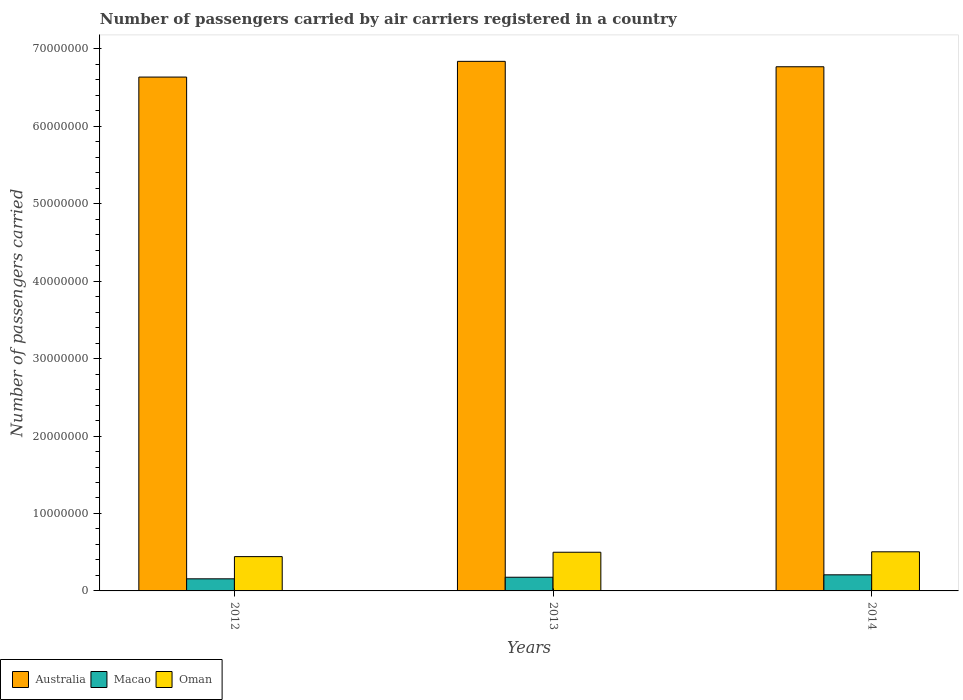How many different coloured bars are there?
Your response must be concise. 3. How many groups of bars are there?
Make the answer very short. 3. Are the number of bars on each tick of the X-axis equal?
Provide a succinct answer. Yes. How many bars are there on the 1st tick from the left?
Give a very brief answer. 3. How many bars are there on the 2nd tick from the right?
Provide a succinct answer. 3. What is the label of the 1st group of bars from the left?
Provide a succinct answer. 2012. In how many cases, is the number of bars for a given year not equal to the number of legend labels?
Provide a succinct answer. 0. What is the number of passengers carried by air carriers in Macao in 2012?
Offer a terse response. 1.56e+06. Across all years, what is the maximum number of passengers carried by air carriers in Oman?
Make the answer very short. 5.05e+06. Across all years, what is the minimum number of passengers carried by air carriers in Macao?
Keep it short and to the point. 1.56e+06. In which year was the number of passengers carried by air carriers in Macao maximum?
Your answer should be very brief. 2014. In which year was the number of passengers carried by air carriers in Oman minimum?
Make the answer very short. 2012. What is the total number of passengers carried by air carriers in Oman in the graph?
Offer a terse response. 1.45e+07. What is the difference between the number of passengers carried by air carriers in Oman in 2012 and that in 2014?
Keep it short and to the point. -6.21e+05. What is the difference between the number of passengers carried by air carriers in Macao in 2012 and the number of passengers carried by air carriers in Oman in 2013?
Provide a short and direct response. -3.43e+06. What is the average number of passengers carried by air carriers in Oman per year?
Offer a terse response. 4.83e+06. In the year 2012, what is the difference between the number of passengers carried by air carriers in Australia and number of passengers carried by air carriers in Oman?
Your answer should be very brief. 6.19e+07. What is the ratio of the number of passengers carried by air carriers in Oman in 2012 to that in 2014?
Your answer should be compact. 0.88. What is the difference between the highest and the second highest number of passengers carried by air carriers in Oman?
Your answer should be very brief. 5.69e+04. What is the difference between the highest and the lowest number of passengers carried by air carriers in Oman?
Give a very brief answer. 6.21e+05. In how many years, is the number of passengers carried by air carriers in Australia greater than the average number of passengers carried by air carriers in Australia taken over all years?
Your answer should be compact. 2. Is the sum of the number of passengers carried by air carriers in Australia in 2013 and 2014 greater than the maximum number of passengers carried by air carriers in Macao across all years?
Your answer should be compact. Yes. What does the 1st bar from the left in 2012 represents?
Offer a very short reply. Australia. What does the 2nd bar from the right in 2013 represents?
Make the answer very short. Macao. How many years are there in the graph?
Ensure brevity in your answer.  3. Are the values on the major ticks of Y-axis written in scientific E-notation?
Give a very brief answer. No. Does the graph contain any zero values?
Offer a terse response. No. Does the graph contain grids?
Your answer should be compact. No. Where does the legend appear in the graph?
Ensure brevity in your answer.  Bottom left. How many legend labels are there?
Provide a succinct answer. 3. How are the legend labels stacked?
Keep it short and to the point. Horizontal. What is the title of the graph?
Provide a succinct answer. Number of passengers carried by air carriers registered in a country. What is the label or title of the Y-axis?
Make the answer very short. Number of passengers carried. What is the Number of passengers carried in Australia in 2012?
Keep it short and to the point. 6.64e+07. What is the Number of passengers carried of Macao in 2012?
Provide a short and direct response. 1.56e+06. What is the Number of passengers carried in Oman in 2012?
Provide a succinct answer. 4.43e+06. What is the Number of passengers carried of Australia in 2013?
Your answer should be very brief. 6.84e+07. What is the Number of passengers carried of Macao in 2013?
Ensure brevity in your answer.  1.77e+06. What is the Number of passengers carried of Oman in 2013?
Offer a terse response. 4.99e+06. What is the Number of passengers carried in Australia in 2014?
Your answer should be very brief. 6.77e+07. What is the Number of passengers carried of Macao in 2014?
Provide a succinct answer. 2.08e+06. What is the Number of passengers carried in Oman in 2014?
Offer a terse response. 5.05e+06. Across all years, what is the maximum Number of passengers carried in Australia?
Your answer should be compact. 6.84e+07. Across all years, what is the maximum Number of passengers carried in Macao?
Your response must be concise. 2.08e+06. Across all years, what is the maximum Number of passengers carried in Oman?
Your response must be concise. 5.05e+06. Across all years, what is the minimum Number of passengers carried in Australia?
Your answer should be compact. 6.64e+07. Across all years, what is the minimum Number of passengers carried in Macao?
Keep it short and to the point. 1.56e+06. Across all years, what is the minimum Number of passengers carried of Oman?
Ensure brevity in your answer.  4.43e+06. What is the total Number of passengers carried in Australia in the graph?
Give a very brief answer. 2.02e+08. What is the total Number of passengers carried of Macao in the graph?
Your answer should be compact. 5.41e+06. What is the total Number of passengers carried of Oman in the graph?
Offer a very short reply. 1.45e+07. What is the difference between the Number of passengers carried of Australia in 2012 and that in 2013?
Provide a short and direct response. -2.03e+06. What is the difference between the Number of passengers carried in Macao in 2012 and that in 2013?
Your response must be concise. -2.05e+05. What is the difference between the Number of passengers carried in Oman in 2012 and that in 2013?
Give a very brief answer. -5.64e+05. What is the difference between the Number of passengers carried of Australia in 2012 and that in 2014?
Provide a short and direct response. -1.33e+06. What is the difference between the Number of passengers carried of Macao in 2012 and that in 2014?
Keep it short and to the point. -5.17e+05. What is the difference between the Number of passengers carried in Oman in 2012 and that in 2014?
Your response must be concise. -6.21e+05. What is the difference between the Number of passengers carried of Australia in 2013 and that in 2014?
Keep it short and to the point. 6.98e+05. What is the difference between the Number of passengers carried in Macao in 2013 and that in 2014?
Provide a succinct answer. -3.12e+05. What is the difference between the Number of passengers carried in Oman in 2013 and that in 2014?
Your answer should be compact. -5.69e+04. What is the difference between the Number of passengers carried in Australia in 2012 and the Number of passengers carried in Macao in 2013?
Offer a very short reply. 6.46e+07. What is the difference between the Number of passengers carried of Australia in 2012 and the Number of passengers carried of Oman in 2013?
Give a very brief answer. 6.14e+07. What is the difference between the Number of passengers carried of Macao in 2012 and the Number of passengers carried of Oman in 2013?
Your response must be concise. -3.43e+06. What is the difference between the Number of passengers carried of Australia in 2012 and the Number of passengers carried of Macao in 2014?
Provide a short and direct response. 6.43e+07. What is the difference between the Number of passengers carried in Australia in 2012 and the Number of passengers carried in Oman in 2014?
Offer a terse response. 6.13e+07. What is the difference between the Number of passengers carried of Macao in 2012 and the Number of passengers carried of Oman in 2014?
Offer a terse response. -3.49e+06. What is the difference between the Number of passengers carried of Australia in 2013 and the Number of passengers carried of Macao in 2014?
Offer a terse response. 6.63e+07. What is the difference between the Number of passengers carried in Australia in 2013 and the Number of passengers carried in Oman in 2014?
Your response must be concise. 6.33e+07. What is the difference between the Number of passengers carried of Macao in 2013 and the Number of passengers carried of Oman in 2014?
Your answer should be compact. -3.28e+06. What is the average Number of passengers carried of Australia per year?
Keep it short and to the point. 6.75e+07. What is the average Number of passengers carried in Macao per year?
Make the answer very short. 1.80e+06. What is the average Number of passengers carried in Oman per year?
Give a very brief answer. 4.83e+06. In the year 2012, what is the difference between the Number of passengers carried in Australia and Number of passengers carried in Macao?
Provide a succinct answer. 6.48e+07. In the year 2012, what is the difference between the Number of passengers carried in Australia and Number of passengers carried in Oman?
Ensure brevity in your answer.  6.19e+07. In the year 2012, what is the difference between the Number of passengers carried in Macao and Number of passengers carried in Oman?
Give a very brief answer. -2.87e+06. In the year 2013, what is the difference between the Number of passengers carried of Australia and Number of passengers carried of Macao?
Ensure brevity in your answer.  6.66e+07. In the year 2013, what is the difference between the Number of passengers carried of Australia and Number of passengers carried of Oman?
Offer a terse response. 6.34e+07. In the year 2013, what is the difference between the Number of passengers carried in Macao and Number of passengers carried in Oman?
Your answer should be very brief. -3.23e+06. In the year 2014, what is the difference between the Number of passengers carried of Australia and Number of passengers carried of Macao?
Provide a short and direct response. 6.56e+07. In the year 2014, what is the difference between the Number of passengers carried in Australia and Number of passengers carried in Oman?
Your answer should be compact. 6.26e+07. In the year 2014, what is the difference between the Number of passengers carried in Macao and Number of passengers carried in Oman?
Your answer should be very brief. -2.97e+06. What is the ratio of the Number of passengers carried in Australia in 2012 to that in 2013?
Your answer should be very brief. 0.97. What is the ratio of the Number of passengers carried in Macao in 2012 to that in 2013?
Provide a short and direct response. 0.88. What is the ratio of the Number of passengers carried in Oman in 2012 to that in 2013?
Offer a very short reply. 0.89. What is the ratio of the Number of passengers carried in Australia in 2012 to that in 2014?
Give a very brief answer. 0.98. What is the ratio of the Number of passengers carried of Macao in 2012 to that in 2014?
Your answer should be compact. 0.75. What is the ratio of the Number of passengers carried of Oman in 2012 to that in 2014?
Keep it short and to the point. 0.88. What is the ratio of the Number of passengers carried of Australia in 2013 to that in 2014?
Give a very brief answer. 1.01. What is the ratio of the Number of passengers carried in Macao in 2013 to that in 2014?
Make the answer very short. 0.85. What is the ratio of the Number of passengers carried in Oman in 2013 to that in 2014?
Offer a very short reply. 0.99. What is the difference between the highest and the second highest Number of passengers carried in Australia?
Offer a very short reply. 6.98e+05. What is the difference between the highest and the second highest Number of passengers carried in Macao?
Keep it short and to the point. 3.12e+05. What is the difference between the highest and the second highest Number of passengers carried in Oman?
Ensure brevity in your answer.  5.69e+04. What is the difference between the highest and the lowest Number of passengers carried in Australia?
Offer a very short reply. 2.03e+06. What is the difference between the highest and the lowest Number of passengers carried of Macao?
Your answer should be compact. 5.17e+05. What is the difference between the highest and the lowest Number of passengers carried in Oman?
Your answer should be compact. 6.21e+05. 